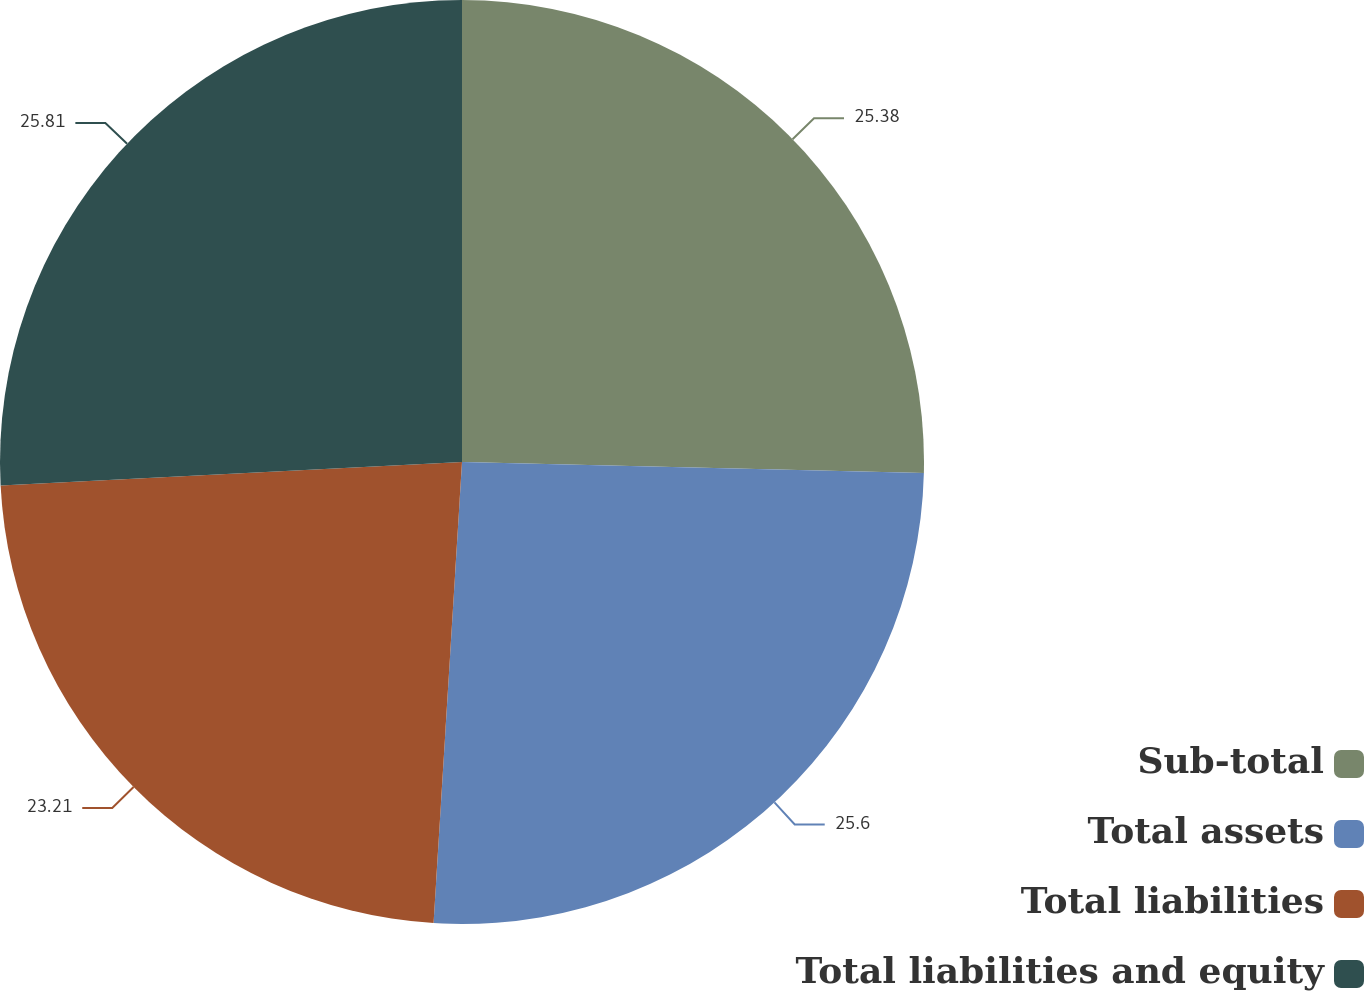Convert chart to OTSL. <chart><loc_0><loc_0><loc_500><loc_500><pie_chart><fcel>Sub-total<fcel>Total assets<fcel>Total liabilities<fcel>Total liabilities and equity<nl><fcel>25.38%<fcel>25.6%<fcel>23.21%<fcel>25.81%<nl></chart> 